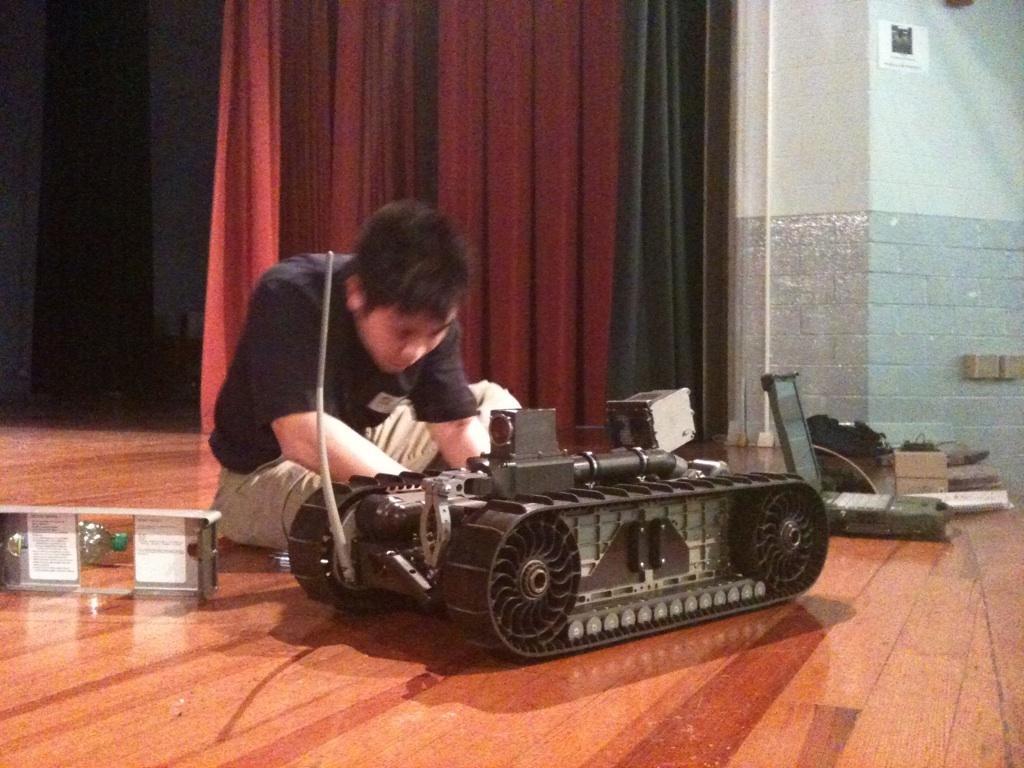How would you summarize this image in a sentence or two? In this image we can see a person sitting on the floor, toy, laptop, walls and curtain. 